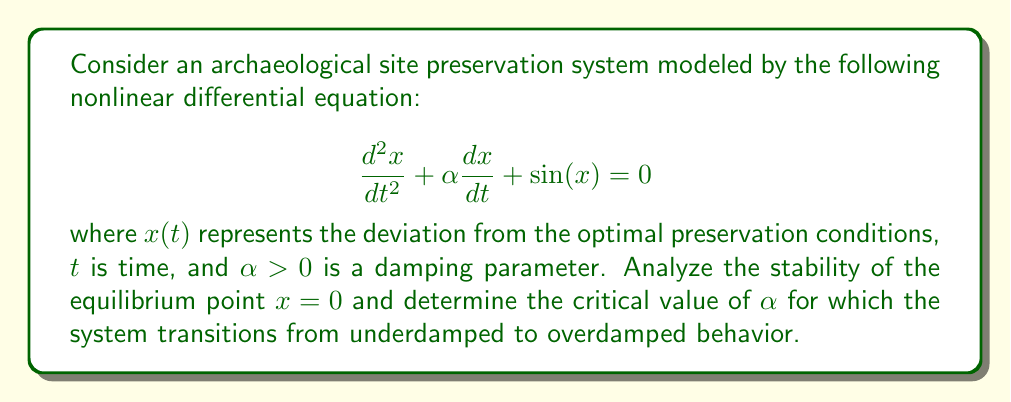Provide a solution to this math problem. 1. Identify the equilibrium points:
   Set $\frac{dx}{dt} = 0$ and $\frac{d^2x}{dt^2} = 0$:
   $$0 + \alpha \cdot 0 + \sin(x) = 0$$
   $$\sin(x) = 0$$
   This gives equilibrium points at $x = 0, \pi, 2\pi, ...$. We focus on $x = 0$.

2. Linearize the system around $x = 0$:
   Let $y = x - 0 = x$. Then:
   $$\frac{d^2y}{dt^2} + \alpha \frac{dy}{dt} + \sin(y) \approx \frac{d^2y}{dt^2} + \alpha \frac{dy}{dt} + y = 0$$
   (Using $\sin(y) \approx y$ for small $y$)

3. Express as a first-order system:
   Let $y_1 = y$ and $y_2 = \frac{dy}{dt}$. Then:
   $$\begin{bmatrix} \frac{dy_1}{dt} \\ \frac{dy_2}{dt} \end{bmatrix} = \begin{bmatrix} 0 & 1 \\ -1 & -\alpha \end{bmatrix} \begin{bmatrix} y_1 \\ y_2 \end{bmatrix}$$

4. Find the eigenvalues of the coefficient matrix:
   $$\det(\lambda I - A) = \det\begin{bmatrix} \lambda & -1 \\ 1 & \lambda + \alpha \end{bmatrix} = \lambda(\lambda + \alpha) + 1 = 0$$
   $$\lambda^2 + \alpha\lambda + 1 = 0$$

5. Solve the characteristic equation:
   $$\lambda = \frac{-\alpha \pm \sqrt{\alpha^2 - 4}}{2}$$

6. Analyze stability:
   - For $\alpha > 0$, Re($\lambda$) < 0, so the equilibrium point is asymptotically stable.
   - The system is underdamped when $\alpha^2 < 4$, critically damped when $\alpha^2 = 4$, and overdamped when $\alpha^2 > 4$.

7. Find the critical value of $\alpha$:
   The transition from underdamped to overdamped occurs when $\alpha^2 = 4$.
   $$\alpha_{critical} = 2$$
Answer: Asymptotically stable; $\alpha_{critical} = 2$ 